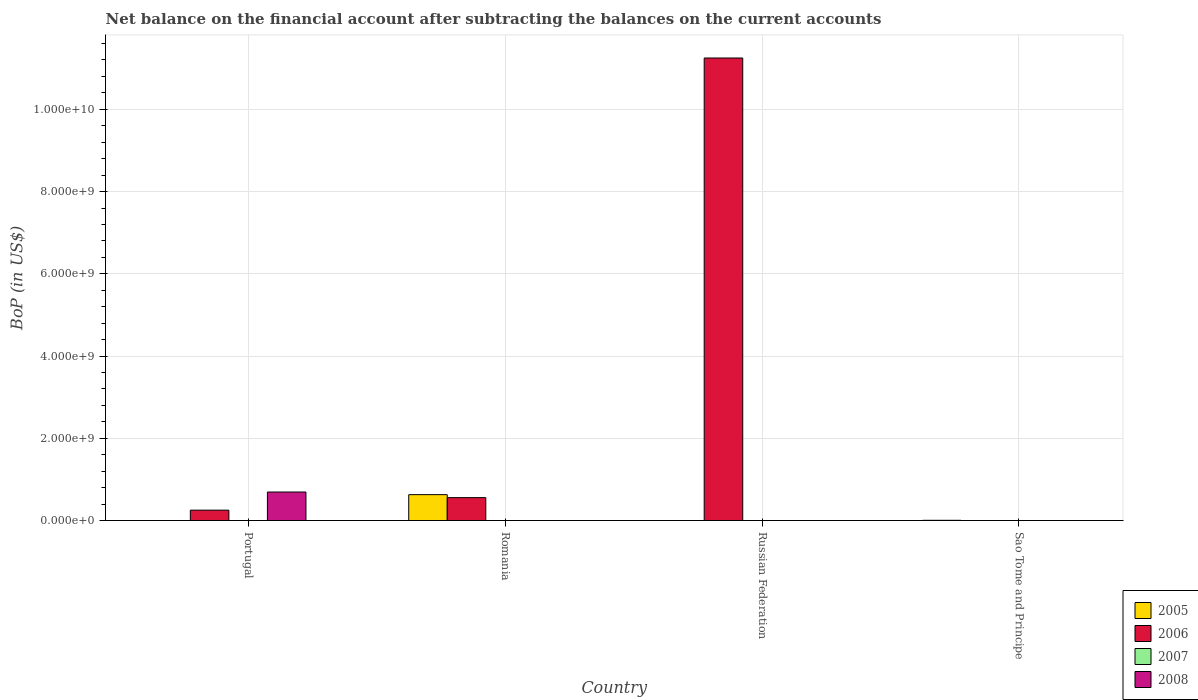Are the number of bars per tick equal to the number of legend labels?
Ensure brevity in your answer.  No. Are the number of bars on each tick of the X-axis equal?
Offer a terse response. No. How many bars are there on the 4th tick from the left?
Ensure brevity in your answer.  1. How many bars are there on the 1st tick from the right?
Give a very brief answer. 1. What is the label of the 4th group of bars from the left?
Your answer should be compact. Sao Tome and Principe. What is the Balance of Payments in 2007 in Russian Federation?
Provide a succinct answer. 0. Across all countries, what is the maximum Balance of Payments in 2008?
Your response must be concise. 6.94e+08. Across all countries, what is the minimum Balance of Payments in 2005?
Ensure brevity in your answer.  0. In which country was the Balance of Payments in 2005 maximum?
Make the answer very short. Romania. What is the total Balance of Payments in 2006 in the graph?
Provide a succinct answer. 1.21e+1. What is the difference between the Balance of Payments in 2007 in Russian Federation and the Balance of Payments in 2005 in Sao Tome and Principe?
Offer a terse response. -6.73e+06. What is the average Balance of Payments in 2006 per country?
Keep it short and to the point. 3.01e+09. What is the difference between the Balance of Payments of/in 2005 and Balance of Payments of/in 2006 in Romania?
Your response must be concise. 7.25e+07. In how many countries, is the Balance of Payments in 2007 greater than 4800000000 US$?
Your answer should be compact. 0. What is the ratio of the Balance of Payments in 2005 in Romania to that in Sao Tome and Principe?
Keep it short and to the point. 93.68. Is the Balance of Payments in 2006 in Portugal less than that in Russian Federation?
Keep it short and to the point. Yes. What is the difference between the highest and the second highest Balance of Payments in 2006?
Your response must be concise. 3.05e+08. What is the difference between the highest and the lowest Balance of Payments in 2008?
Offer a very short reply. 6.94e+08. In how many countries, is the Balance of Payments in 2005 greater than the average Balance of Payments in 2005 taken over all countries?
Your answer should be compact. 1. Is it the case that in every country, the sum of the Balance of Payments in 2005 and Balance of Payments in 2007 is greater than the sum of Balance of Payments in 2008 and Balance of Payments in 2006?
Give a very brief answer. No. How many bars are there?
Provide a short and direct response. 6. Are all the bars in the graph horizontal?
Make the answer very short. No. Does the graph contain grids?
Give a very brief answer. Yes. Where does the legend appear in the graph?
Make the answer very short. Bottom right. How many legend labels are there?
Make the answer very short. 4. What is the title of the graph?
Your response must be concise. Net balance on the financial account after subtracting the balances on the current accounts. Does "1981" appear as one of the legend labels in the graph?
Make the answer very short. No. What is the label or title of the Y-axis?
Make the answer very short. BoP (in US$). What is the BoP (in US$) in 2005 in Portugal?
Your answer should be very brief. 0. What is the BoP (in US$) in 2006 in Portugal?
Provide a short and direct response. 2.53e+08. What is the BoP (in US$) of 2007 in Portugal?
Provide a succinct answer. 0. What is the BoP (in US$) in 2008 in Portugal?
Your response must be concise. 6.94e+08. What is the BoP (in US$) in 2005 in Romania?
Offer a very short reply. 6.30e+08. What is the BoP (in US$) in 2006 in Romania?
Your answer should be compact. 5.58e+08. What is the BoP (in US$) in 2005 in Russian Federation?
Your answer should be compact. 0. What is the BoP (in US$) in 2006 in Russian Federation?
Make the answer very short. 1.12e+1. What is the BoP (in US$) in 2007 in Russian Federation?
Make the answer very short. 0. What is the BoP (in US$) in 2008 in Russian Federation?
Offer a terse response. 0. What is the BoP (in US$) of 2005 in Sao Tome and Principe?
Your response must be concise. 6.73e+06. What is the BoP (in US$) of 2008 in Sao Tome and Principe?
Provide a succinct answer. 0. Across all countries, what is the maximum BoP (in US$) of 2005?
Keep it short and to the point. 6.30e+08. Across all countries, what is the maximum BoP (in US$) of 2006?
Your answer should be compact. 1.12e+1. Across all countries, what is the maximum BoP (in US$) in 2008?
Your response must be concise. 6.94e+08. Across all countries, what is the minimum BoP (in US$) in 2005?
Your response must be concise. 0. Across all countries, what is the minimum BoP (in US$) in 2008?
Offer a very short reply. 0. What is the total BoP (in US$) in 2005 in the graph?
Offer a terse response. 6.37e+08. What is the total BoP (in US$) of 2006 in the graph?
Your answer should be compact. 1.21e+1. What is the total BoP (in US$) in 2008 in the graph?
Offer a terse response. 6.94e+08. What is the difference between the BoP (in US$) of 2006 in Portugal and that in Romania?
Provide a succinct answer. -3.05e+08. What is the difference between the BoP (in US$) of 2006 in Portugal and that in Russian Federation?
Give a very brief answer. -1.10e+1. What is the difference between the BoP (in US$) in 2006 in Romania and that in Russian Federation?
Offer a terse response. -1.07e+1. What is the difference between the BoP (in US$) of 2005 in Romania and that in Sao Tome and Principe?
Offer a very short reply. 6.24e+08. What is the difference between the BoP (in US$) of 2005 in Romania and the BoP (in US$) of 2006 in Russian Federation?
Ensure brevity in your answer.  -1.06e+1. What is the average BoP (in US$) in 2005 per country?
Your response must be concise. 1.59e+08. What is the average BoP (in US$) in 2006 per country?
Your response must be concise. 3.01e+09. What is the average BoP (in US$) in 2007 per country?
Give a very brief answer. 0. What is the average BoP (in US$) of 2008 per country?
Provide a succinct answer. 1.74e+08. What is the difference between the BoP (in US$) of 2006 and BoP (in US$) of 2008 in Portugal?
Your answer should be very brief. -4.41e+08. What is the difference between the BoP (in US$) of 2005 and BoP (in US$) of 2006 in Romania?
Provide a short and direct response. 7.25e+07. What is the ratio of the BoP (in US$) in 2006 in Portugal to that in Romania?
Give a very brief answer. 0.45. What is the ratio of the BoP (in US$) in 2006 in Portugal to that in Russian Federation?
Your answer should be compact. 0.02. What is the ratio of the BoP (in US$) in 2006 in Romania to that in Russian Federation?
Your response must be concise. 0.05. What is the ratio of the BoP (in US$) in 2005 in Romania to that in Sao Tome and Principe?
Provide a short and direct response. 93.68. What is the difference between the highest and the second highest BoP (in US$) in 2006?
Your answer should be compact. 1.07e+1. What is the difference between the highest and the lowest BoP (in US$) in 2005?
Provide a short and direct response. 6.30e+08. What is the difference between the highest and the lowest BoP (in US$) in 2006?
Your answer should be very brief. 1.12e+1. What is the difference between the highest and the lowest BoP (in US$) in 2008?
Your answer should be very brief. 6.94e+08. 